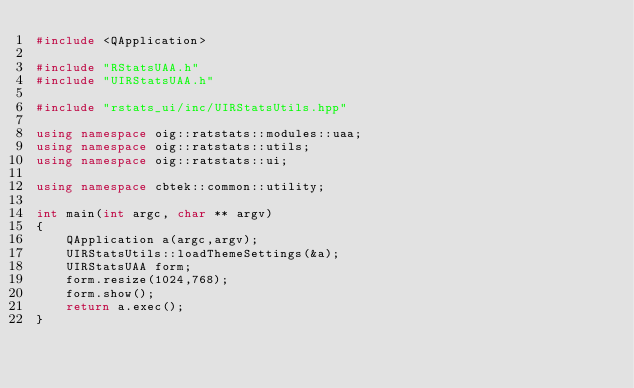<code> <loc_0><loc_0><loc_500><loc_500><_C++_>#include <QApplication>

#include "RStatsUAA.h"
#include "UIRStatsUAA.h"

#include "rstats_ui/inc/UIRStatsUtils.hpp"

using namespace oig::ratstats::modules::uaa;
using namespace oig::ratstats::utils;
using namespace oig::ratstats::ui;

using namespace cbtek::common::utility;

int main(int argc, char ** argv)
{
    QApplication a(argc,argv);
    UIRStatsUtils::loadThemeSettings(&a);
    UIRStatsUAA form;
    form.resize(1024,768);
    form.show();
    return a.exec();
}
</code> 